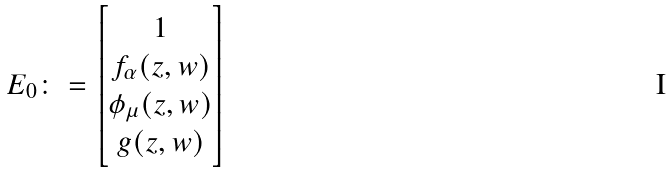<formula> <loc_0><loc_0><loc_500><loc_500>E _ { 0 } \colon = \begin{bmatrix} 1 \\ f _ { \alpha } ( z , w ) \\ \phi _ { \mu } ( z , w ) \\ g ( z , w ) \end{bmatrix}</formula> 